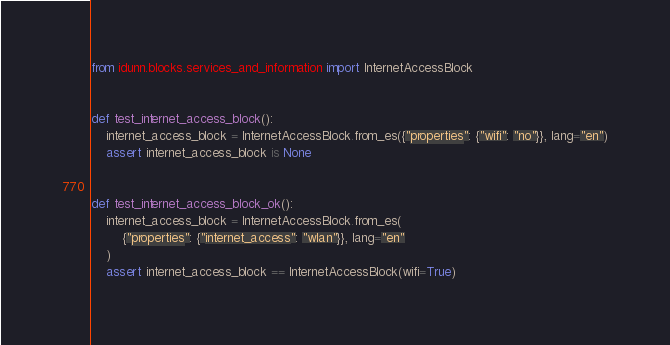Convert code to text. <code><loc_0><loc_0><loc_500><loc_500><_Python_>from idunn.blocks.services_and_information import InternetAccessBlock


def test_internet_access_block():
    internet_access_block = InternetAccessBlock.from_es({"properties": {"wifi": "no"}}, lang="en")
    assert internet_access_block is None


def test_internet_access_block_ok():
    internet_access_block = InternetAccessBlock.from_es(
        {"properties": {"internet_access": "wlan"}}, lang="en"
    )
    assert internet_access_block == InternetAccessBlock(wifi=True)
</code> 